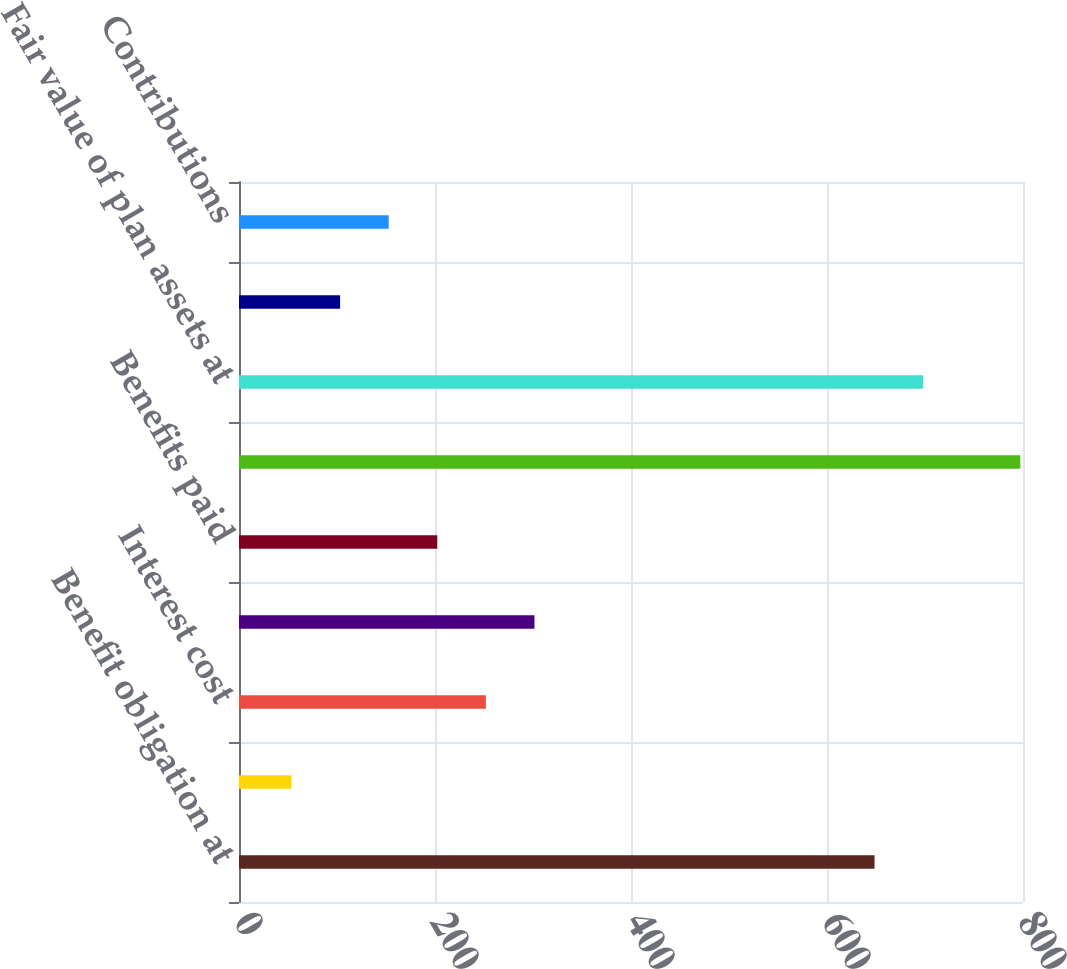Convert chart to OTSL. <chart><loc_0><loc_0><loc_500><loc_500><bar_chart><fcel>Benefit obligation at<fcel>Service cost<fcel>Interest cost<fcel>Actuarial (gain) loss<fcel>Benefits paid<fcel>Benefit obligation at end of<fcel>Fair value of plan assets at<fcel>Actual return on plan assets<fcel>Contributions<nl><fcel>648.54<fcel>53.58<fcel>251.9<fcel>301.48<fcel>202.32<fcel>797.28<fcel>698.12<fcel>103.16<fcel>152.74<nl></chart> 